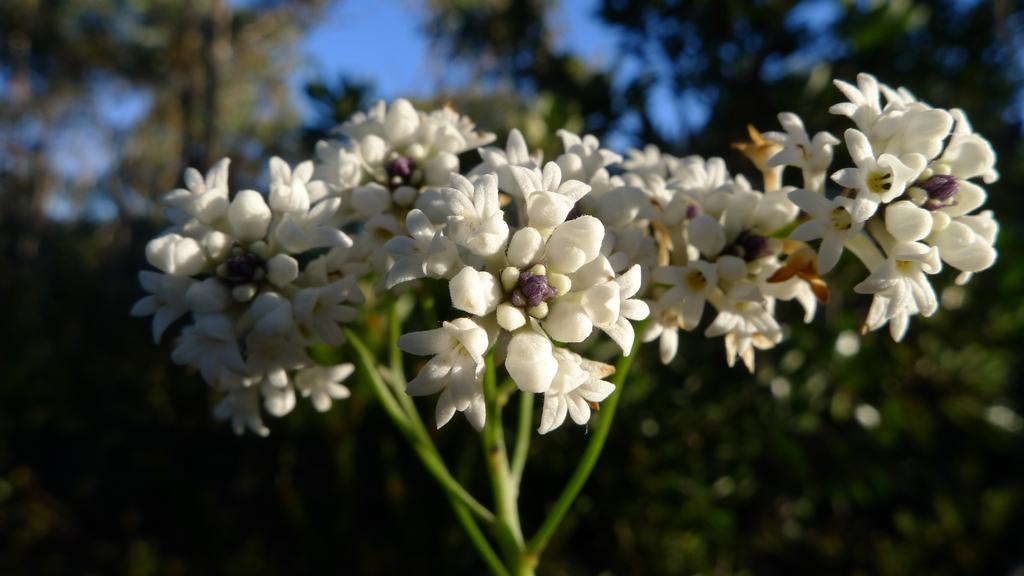What is the main subject in the center of the image? There are flowers in the center of the image. What can be seen in the background of the image? There are trees and the sky visible in the background of the image. Where is the goat located in the image? There is no goat present in the image. What sound does the bell make in the image? There is no bell present in the image. 